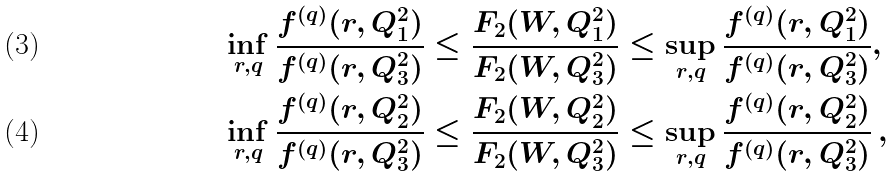Convert formula to latex. <formula><loc_0><loc_0><loc_500><loc_500>\inf _ { r , q } \frac { f ^ { ( q ) } ( r , Q _ { 1 } ^ { 2 } ) } { f ^ { ( q ) } ( r , Q _ { 3 } ^ { 2 } ) } & \leq \frac { F _ { 2 } ( W , Q _ { 1 } ^ { 2 } ) } { F _ { 2 } ( W , Q _ { 3 } ^ { 2 } ) } \leq \sup _ { r , q } \frac { f ^ { ( q ) } ( r , Q _ { 1 } ^ { 2 } ) } { f ^ { ( q ) } ( r , Q _ { 3 } ^ { 2 } ) } , \\ \inf _ { r , q } \frac { f ^ { ( q ) } ( r , Q _ { 2 } ^ { 2 } ) } { f ^ { ( q ) } ( r , Q _ { 3 } ^ { 2 } ) } & \leq \frac { F _ { 2 } ( W , Q _ { 2 } ^ { 2 } ) } { F _ { 2 } ( W , Q _ { 3 } ^ { 2 } ) } \leq \sup _ { r , q } \frac { f ^ { ( q ) } ( r , Q _ { 2 } ^ { 2 } ) } { f ^ { ( q ) } ( r , Q _ { 3 } ^ { 2 } ) } \, ,</formula> 